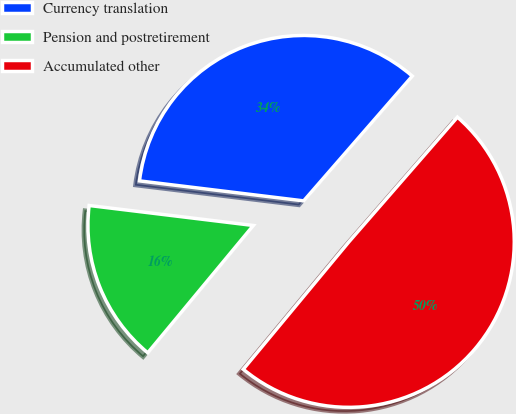<chart> <loc_0><loc_0><loc_500><loc_500><pie_chart><fcel>Currency translation<fcel>Pension and postretirement<fcel>Accumulated other<nl><fcel>34.47%<fcel>15.91%<fcel>49.62%<nl></chart> 